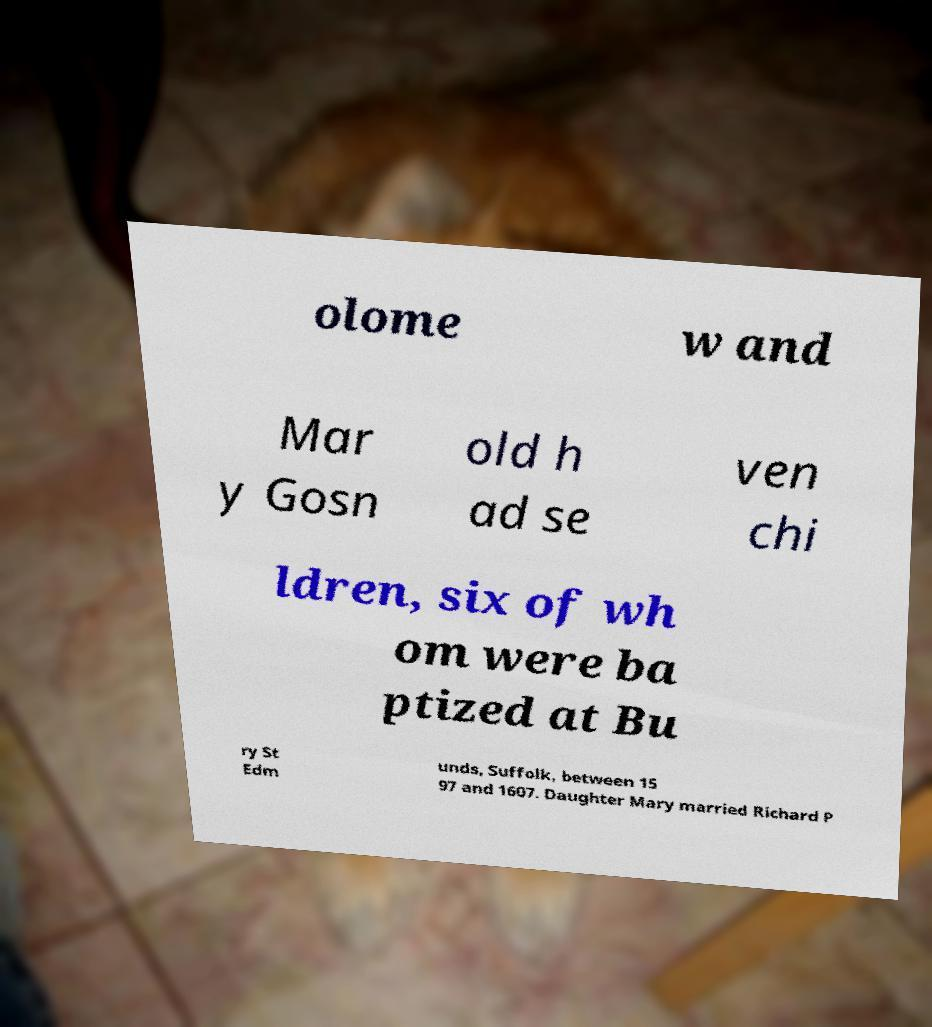I need the written content from this picture converted into text. Can you do that? olome w and Mar y Gosn old h ad se ven chi ldren, six of wh om were ba ptized at Bu ry St Edm unds, Suffolk, between 15 97 and 1607. Daughter Mary married Richard P 